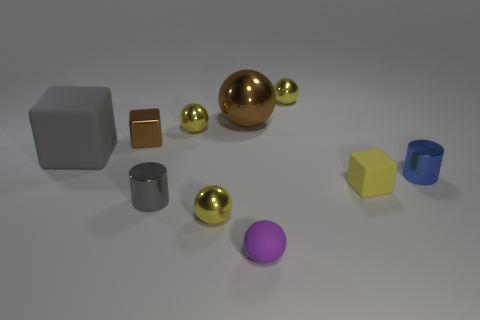There is a big ball; is it the same color as the small block behind the large gray block?
Ensure brevity in your answer.  Yes. Are there any other things that have the same size as the metal block?
Provide a succinct answer. Yes. There is a rubber object left of the cylinder that is left of the blue object; how big is it?
Keep it short and to the point. Large. What number of things are either small purple rubber objects or yellow spheres behind the yellow block?
Your answer should be compact. 3. Do the tiny yellow metal object that is on the right side of the purple thing and the small purple rubber thing have the same shape?
Provide a short and direct response. Yes. There is a small cylinder behind the matte cube that is right of the brown shiny sphere; how many yellow rubber things are right of it?
Your answer should be compact. 0. How many objects are blue shiny cylinders or small metallic objects?
Keep it short and to the point. 6. Is the shape of the large brown object the same as the tiny yellow shiny object that is in front of the big matte block?
Keep it short and to the point. Yes. There is a small purple thing that is in front of the brown ball; what is its shape?
Your answer should be very brief. Sphere. Is the gray rubber thing the same shape as the small yellow matte thing?
Offer a terse response. Yes. 